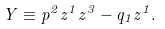<formula> <loc_0><loc_0><loc_500><loc_500>Y \equiv p ^ { 2 } z ^ { 1 } z ^ { 3 } - q _ { 1 } z ^ { 1 } .</formula> 